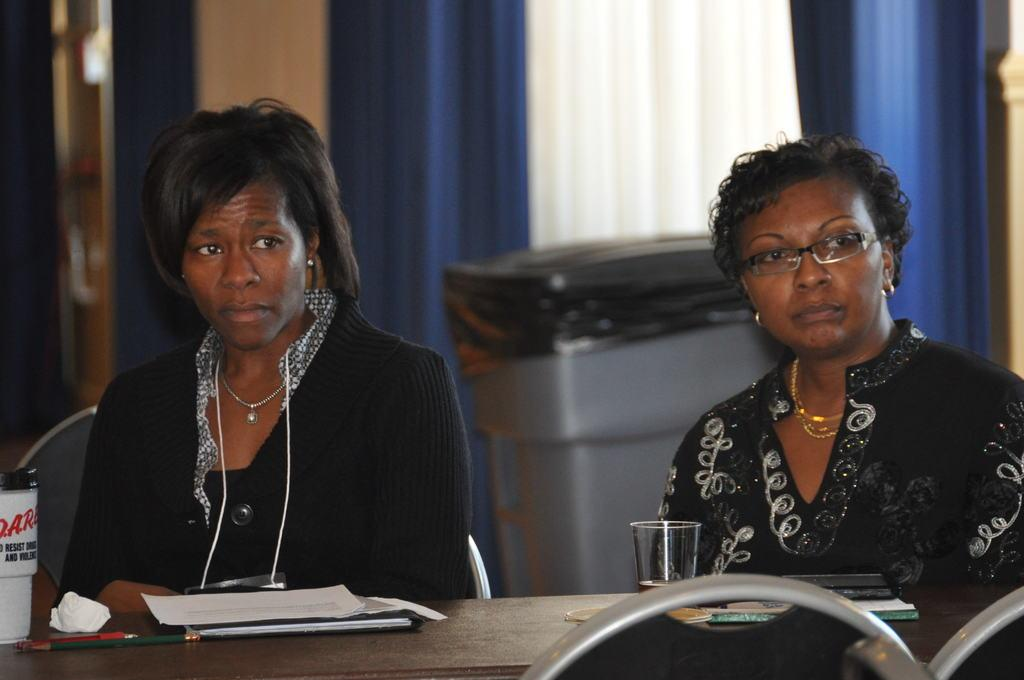How many women are in the image? There are 2 women in the image. What are the women doing in the image? The women are sitting on chairs. What is in front of the women? There is a table in front of the women. What items can be seen on the table? There are books, a glass, papers, and 2 pens on the table. What type of cow can be seen grazing near the volcano in the image? There is no cow or volcano present in the image. 